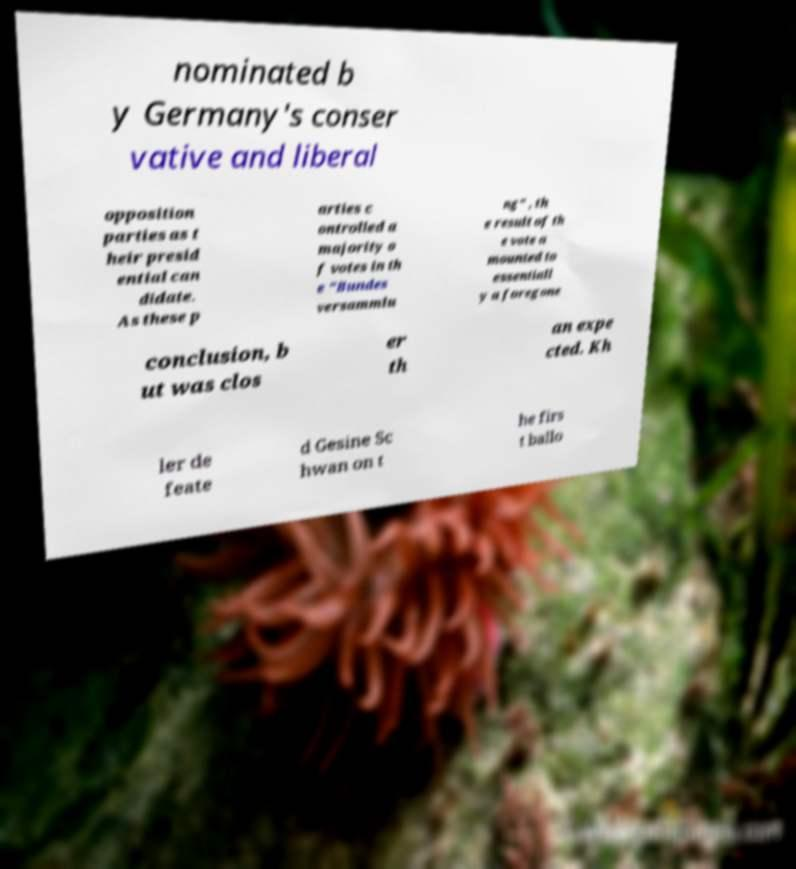I need the written content from this picture converted into text. Can you do that? nominated b y Germany's conser vative and liberal opposition parties as t heir presid ential can didate. As these p arties c ontrolled a majority o f votes in th e "Bundes versammlu ng" , th e result of th e vote a mounted to essentiall y a foregone conclusion, b ut was clos er th an expe cted. Kh ler de feate d Gesine Sc hwan on t he firs t ballo 